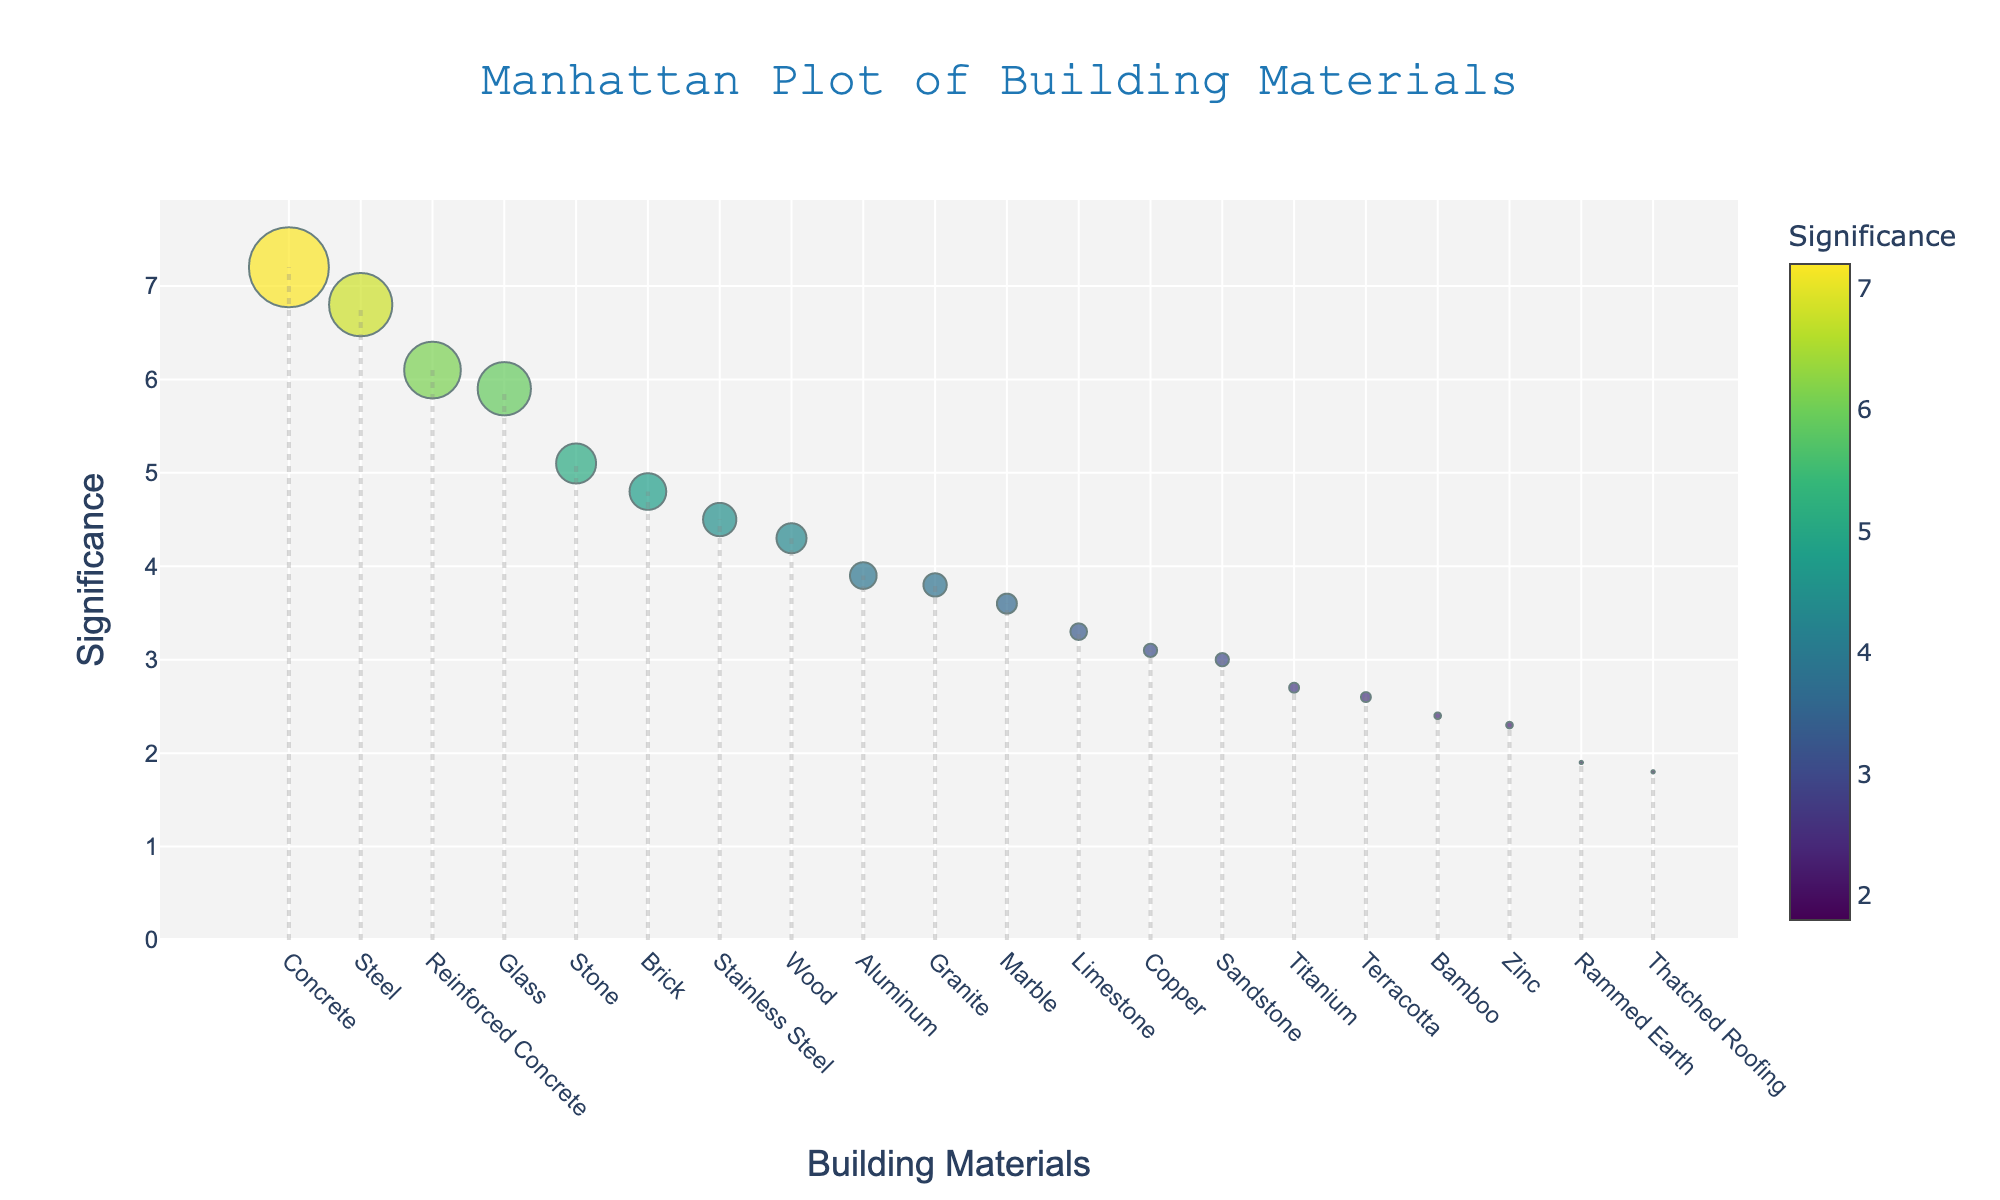How many materials are represented in the plot? Count the number of different materials listed on the x-axis. In this case, there are 20 materials
Answer: 20 Which building material has the highest significance? Identify the material with the highest y-value (Significance). The highest point corresponds to Concrete with a significance of 7.2
Answer: Concrete What is the average frequency of materials above a significance level of 5? Identify materials with a significance greater than 5: Concrete, Steel, Glass, Reinforced Concrete, and Stone. Sum their frequencies (120 + 95 + 80 + 85 + 60) and divide by the number of materials (5). (120 + 95 + 80 + 85 + 60) / 5 = 88
Answer: 88 Between Glass and Wood, which has a higher significance? Compare the y-values (Significance) of Glass and Wood. Glass has 5.9 while Wood has 4.3.
Answer: Glass What material has the smallest marker size, indicating the lowest frequency? The size of the marker is proportional to the frequency. The smallest marker corresponds to Rammed Earth and Thatched Roofing, both with a frequency of 5
Answer: Rammed Earth and Thatched Roofing What is the total frequency of materials with significance below 3? Identify materials with a significance below 3: Titanium, Zinc, Bamboo, Rammed Earth, Thatched Roofing, Sandstone, and Copper. Sum their frequencies (15 + 10 + 10 + 5 + 5 + 20 + 20). 15 + 10 + 10 + 5 + 5 + 20 + 20 = 85
Answer: 85 Is Aluminum more significant than Marble? Compare the significance values of Aluminum and Marble. Aluminum has a significance of 3.9 while Marble has 3.6.
Answer: Yes Which material has the largest marker size but a significance below 5? Identify the material with the highest frequency (as indicated by marker size) but with a significance below 5. This corresponds to Stainless Steel with a frequency of 50 and a significance of 4.5
Answer: Stainless Steel 